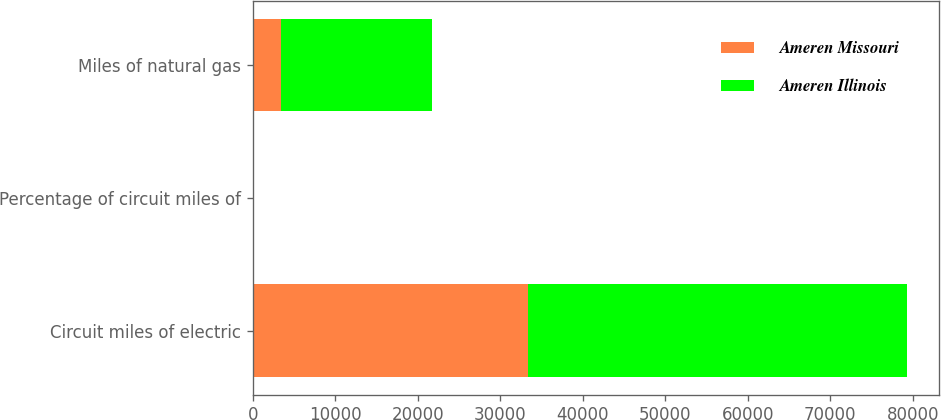<chart> <loc_0><loc_0><loc_500><loc_500><stacked_bar_chart><ecel><fcel>Circuit miles of electric<fcel>Percentage of circuit miles of<fcel>Miles of natural gas<nl><fcel>Ameren Missouri<fcel>33346<fcel>23<fcel>3357<nl><fcel>Ameren Illinois<fcel>45897<fcel>15<fcel>18364<nl></chart> 